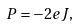Convert formula to latex. <formula><loc_0><loc_0><loc_500><loc_500>P = - 2 e J ,</formula> 